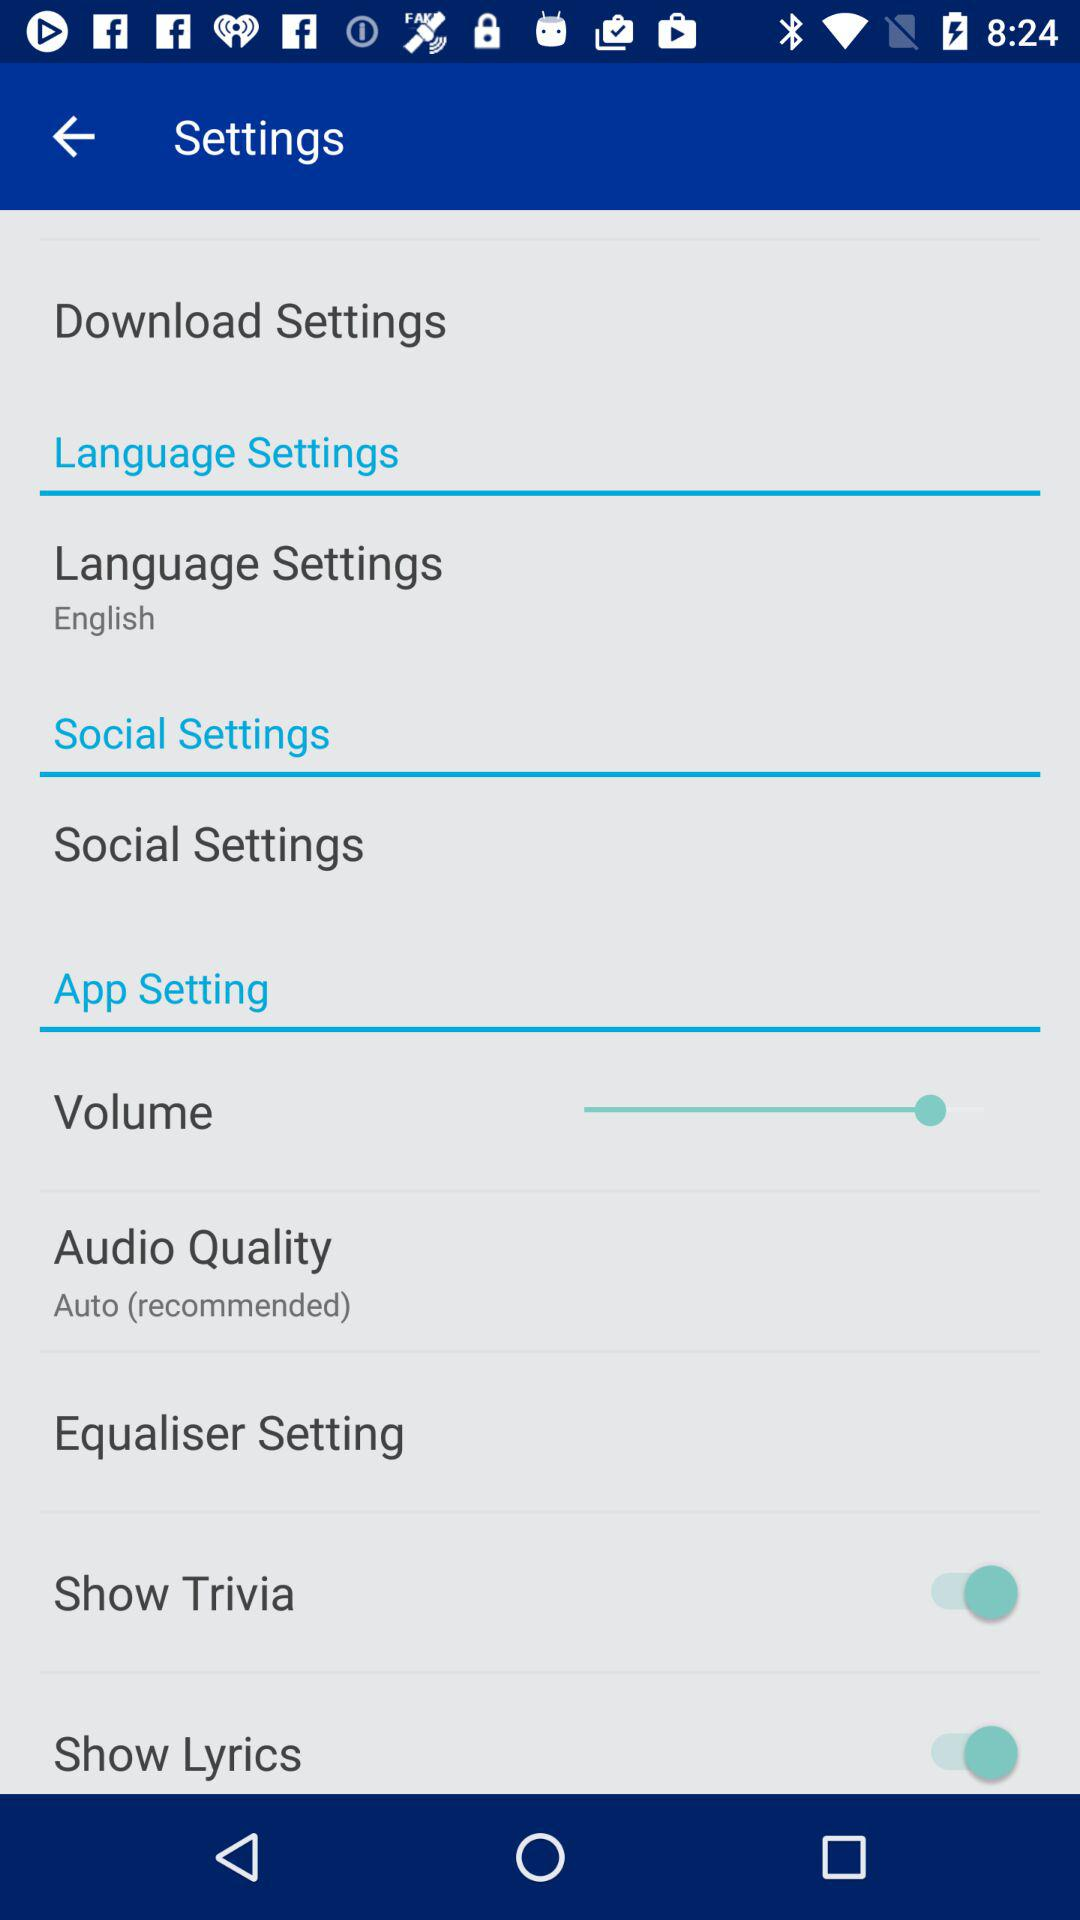What's the audio quality type? The audio quality type is "Auto (recommended)". 